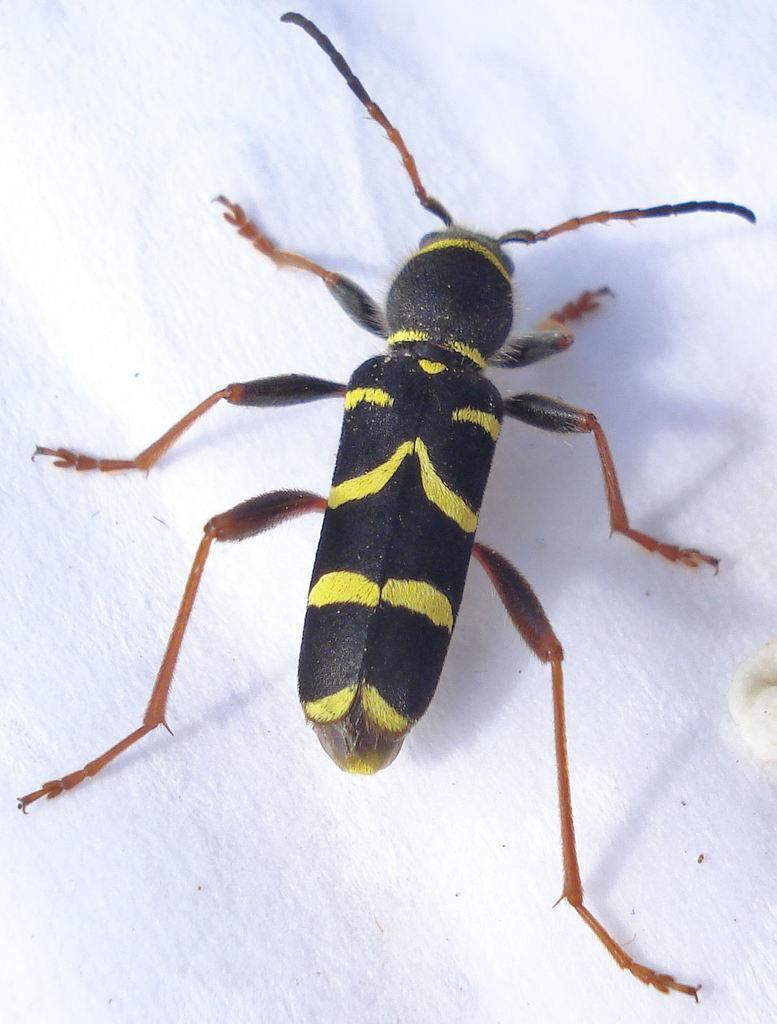How would you summarize this image in a sentence or two? In this picture we can see an insect. 